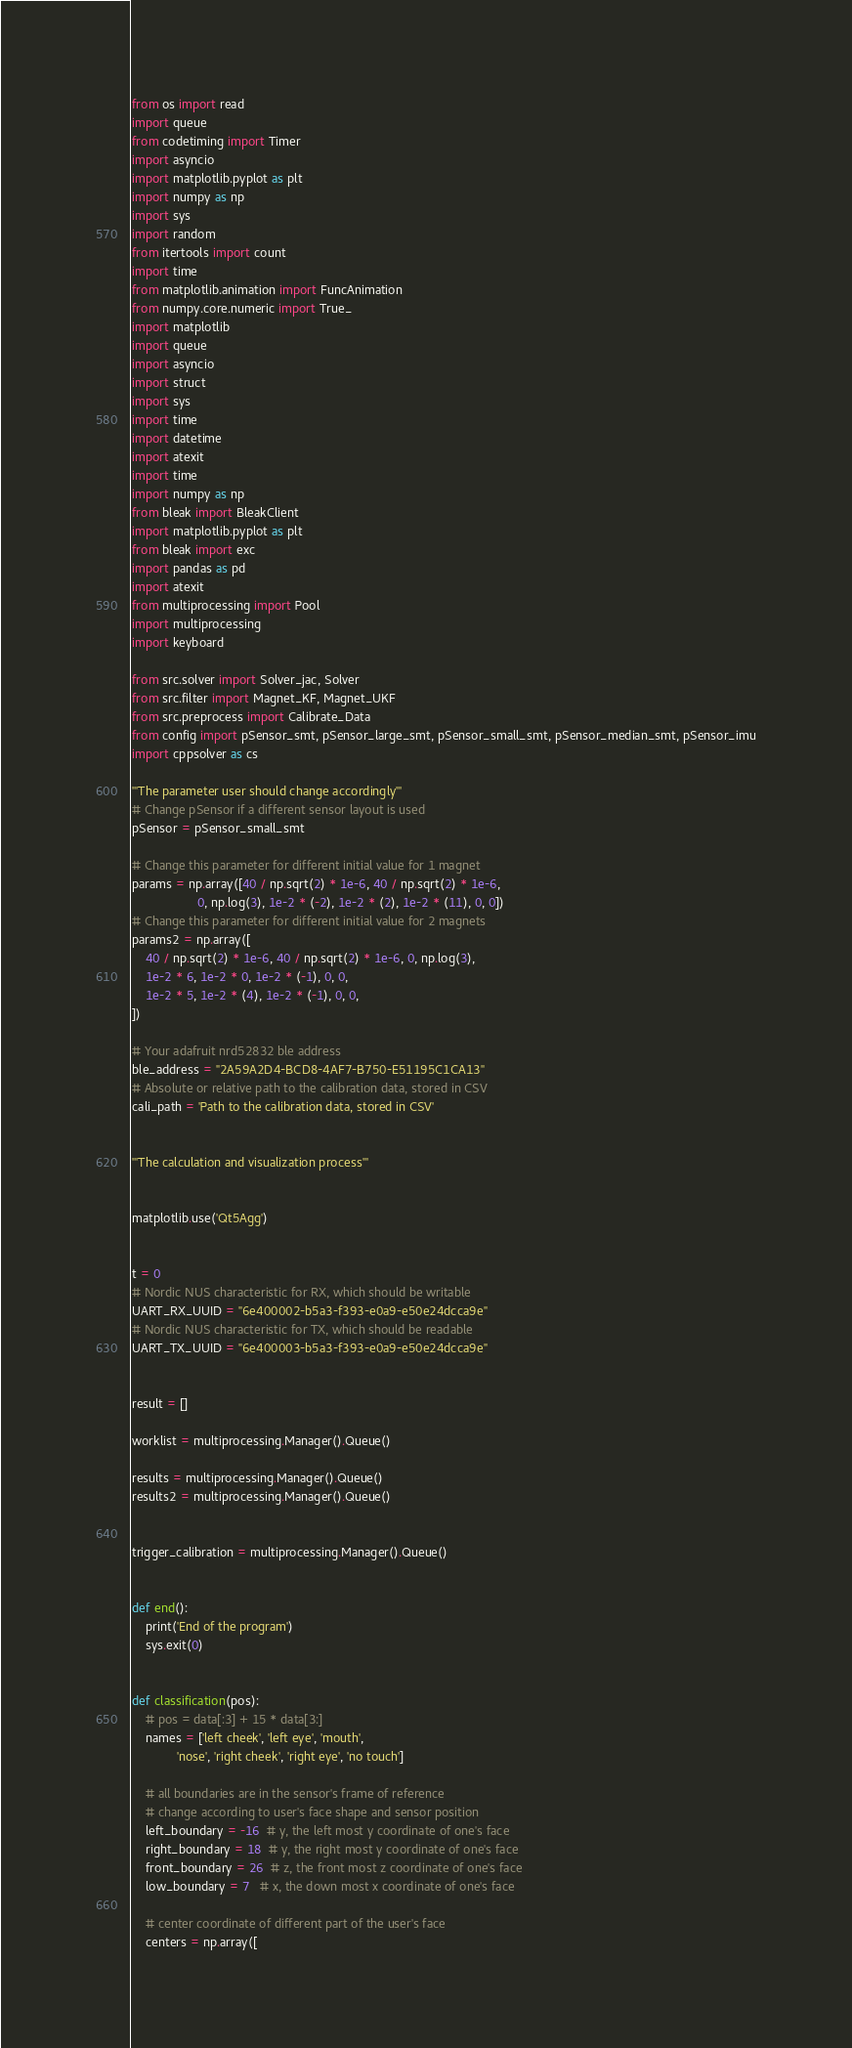Convert code to text. <code><loc_0><loc_0><loc_500><loc_500><_Python_>from os import read
import queue
from codetiming import Timer
import asyncio
import matplotlib.pyplot as plt
import numpy as np
import sys
import random
from itertools import count
import time
from matplotlib.animation import FuncAnimation
from numpy.core.numeric import True_
import matplotlib
import queue
import asyncio
import struct
import sys
import time
import datetime
import atexit
import time
import numpy as np
from bleak import BleakClient
import matplotlib.pyplot as plt
from bleak import exc
import pandas as pd
import atexit
from multiprocessing import Pool
import multiprocessing
import keyboard

from src.solver import Solver_jac, Solver
from src.filter import Magnet_KF, Magnet_UKF
from src.preprocess import Calibrate_Data
from config import pSensor_smt, pSensor_large_smt, pSensor_small_smt, pSensor_median_smt, pSensor_imu
import cppsolver as cs

'''The parameter user should change accordingly'''
# Change pSensor if a different sensor layout is used
pSensor = pSensor_small_smt

# Change this parameter for different initial value for 1 magnet
params = np.array([40 / np.sqrt(2) * 1e-6, 40 / np.sqrt(2) * 1e-6,
                   0, np.log(3), 1e-2 * (-2), 1e-2 * (2), 1e-2 * (11), 0, 0])
# Change this parameter for different initial value for 2 magnets
params2 = np.array([
    40 / np.sqrt(2) * 1e-6, 40 / np.sqrt(2) * 1e-6, 0, np.log(3),
    1e-2 * 6, 1e-2 * 0, 1e-2 * (-1), 0, 0,
    1e-2 * 5, 1e-2 * (4), 1e-2 * (-1), 0, 0,
])

# Your adafruit nrd52832 ble address
ble_address = "2A59A2D4-BCD8-4AF7-B750-E51195C1CA13"
# Absolute or relative path to the calibration data, stored in CSV
cali_path = 'Path to the calibration data, stored in CSV'


'''The calculation and visualization process'''


matplotlib.use('Qt5Agg')


t = 0
# Nordic NUS characteristic for RX, which should be writable
UART_RX_UUID = "6e400002-b5a3-f393-e0a9-e50e24dcca9e"
# Nordic NUS characteristic for TX, which should be readable
UART_TX_UUID = "6e400003-b5a3-f393-e0a9-e50e24dcca9e"


result = []

worklist = multiprocessing.Manager().Queue()

results = multiprocessing.Manager().Queue()
results2 = multiprocessing.Manager().Queue()


trigger_calibration = multiprocessing.Manager().Queue()


def end():
    print('End of the program')
    sys.exit(0)


def classification(pos):
    # pos = data[:3] + 15 * data[3:]
    names = ['left cheek', 'left eye', 'mouth',
             'nose', 'right cheek', 'right eye', 'no touch']

    # all boundaries are in the sensor's frame of reference
    # change according to user's face shape and sensor position
    left_boundary = -16  # y, the left most y coordinate of one's face
    right_boundary = 18  # y, the right most y coordinate of one's face
    front_boundary = 26  # z, the front most z coordinate of one's face
    low_boundary = 7   # x, the down most x coordinate of one's face

    # center coordinate of different part of the user's face
    centers = np.array([</code> 